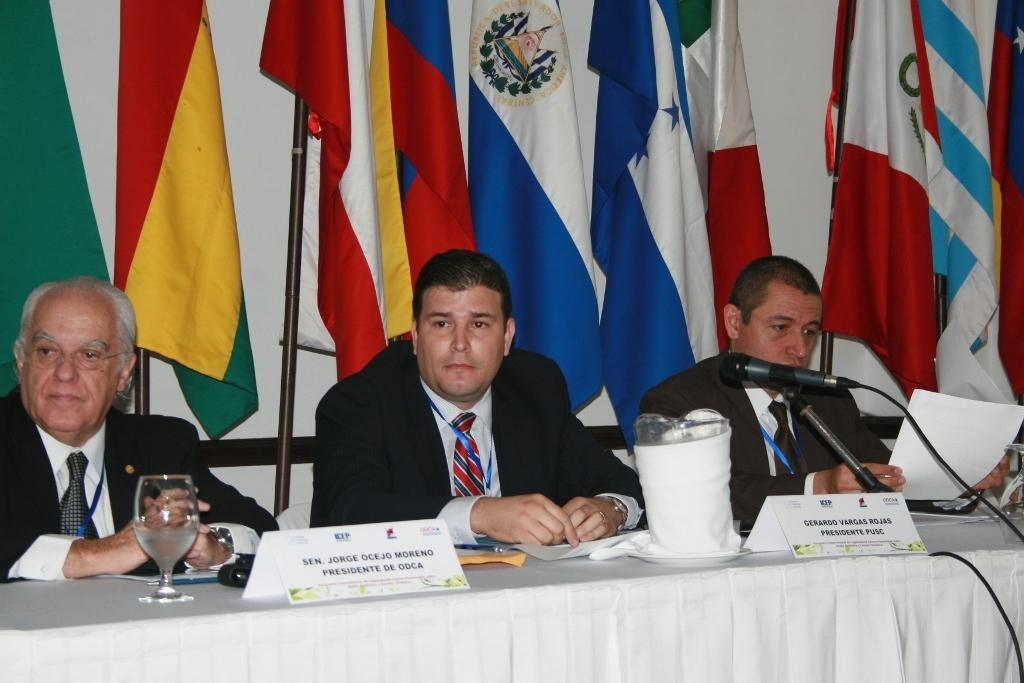How many people are sitting in the image? There are three people sitting on chairs in the image. What can be seen on the stand in the image? There is a mic on the stand in the image. What type of objects are present on the table in the image? There are objects on the table in the image, but the specific objects are not mentioned in the facts. What is the background of the image characterized by? The background of the image features colorful flags. What type of bean is being used to fix the error in the image? There is no bean or error present in the image. Are there any police officers visible in the image? There is no mention of police officers in the provided facts, so it cannot be determined if they are present in the image. 